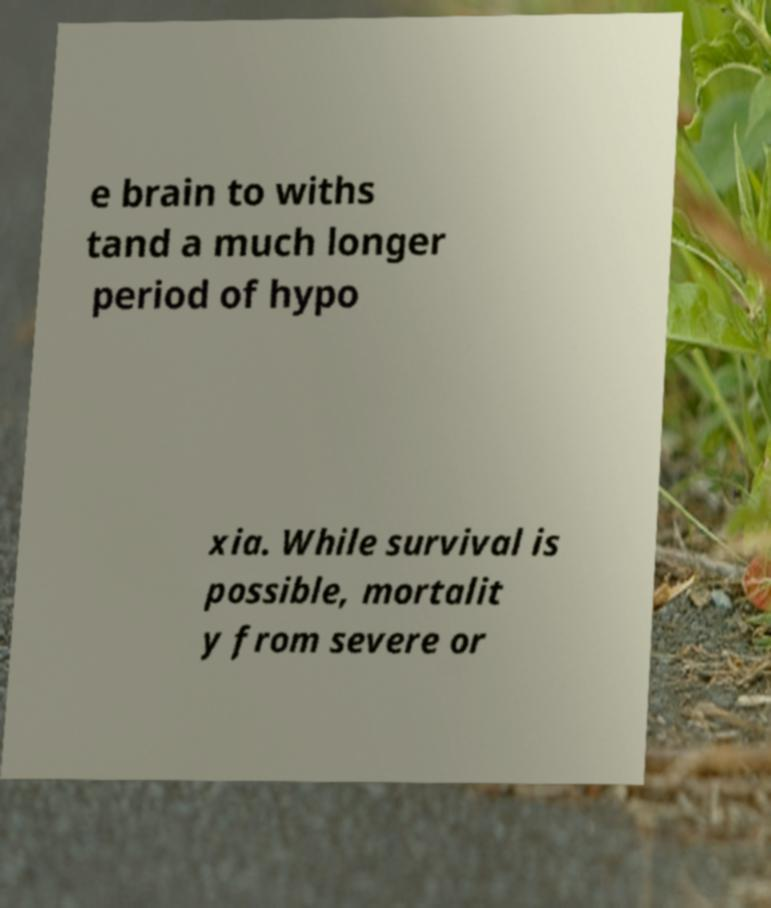Could you extract and type out the text from this image? e brain to withs tand a much longer period of hypo xia. While survival is possible, mortalit y from severe or 